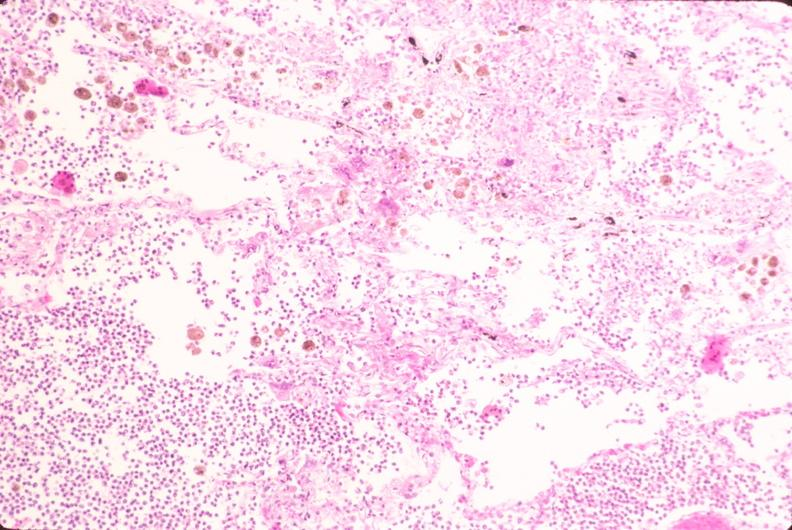does right side atresia show lung, bronchopneumonia, bacterial?
Answer the question using a single word or phrase. No 